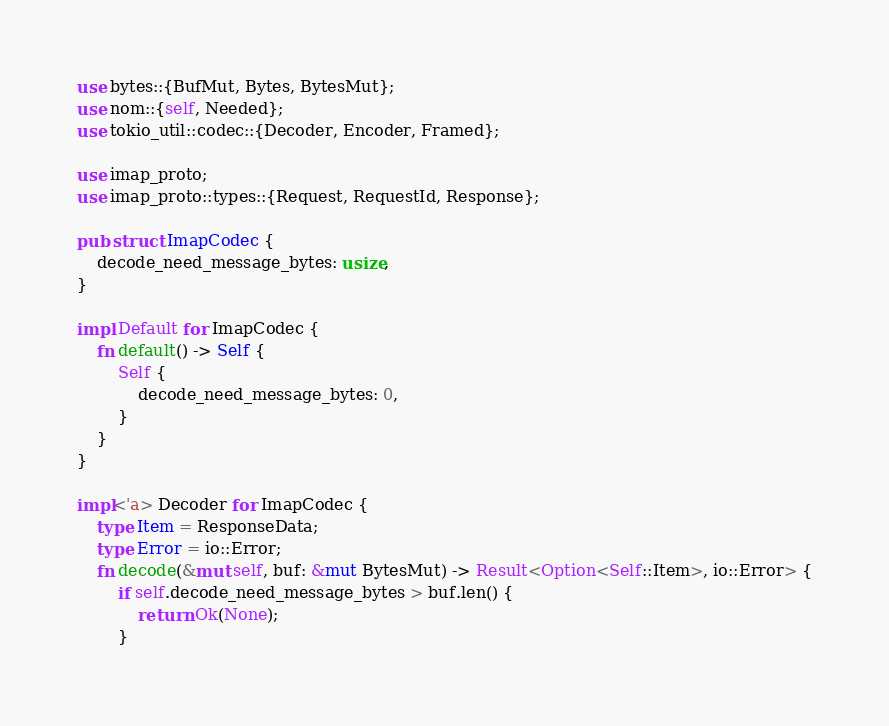Convert code to text. <code><loc_0><loc_0><loc_500><loc_500><_Rust_>use bytes::{BufMut, Bytes, BytesMut};
use nom::{self, Needed};
use tokio_util::codec::{Decoder, Encoder, Framed};

use imap_proto;
use imap_proto::types::{Request, RequestId, Response};

pub struct ImapCodec {
    decode_need_message_bytes: usize,
}

impl Default for ImapCodec {
    fn default() -> Self {
        Self {
            decode_need_message_bytes: 0,
        }
    }
}

impl<'a> Decoder for ImapCodec {
    type Item = ResponseData;
    type Error = io::Error;
    fn decode(&mut self, buf: &mut BytesMut) -> Result<Option<Self::Item>, io::Error> {
        if self.decode_need_message_bytes > buf.len() {
            return Ok(None);
        }</code> 